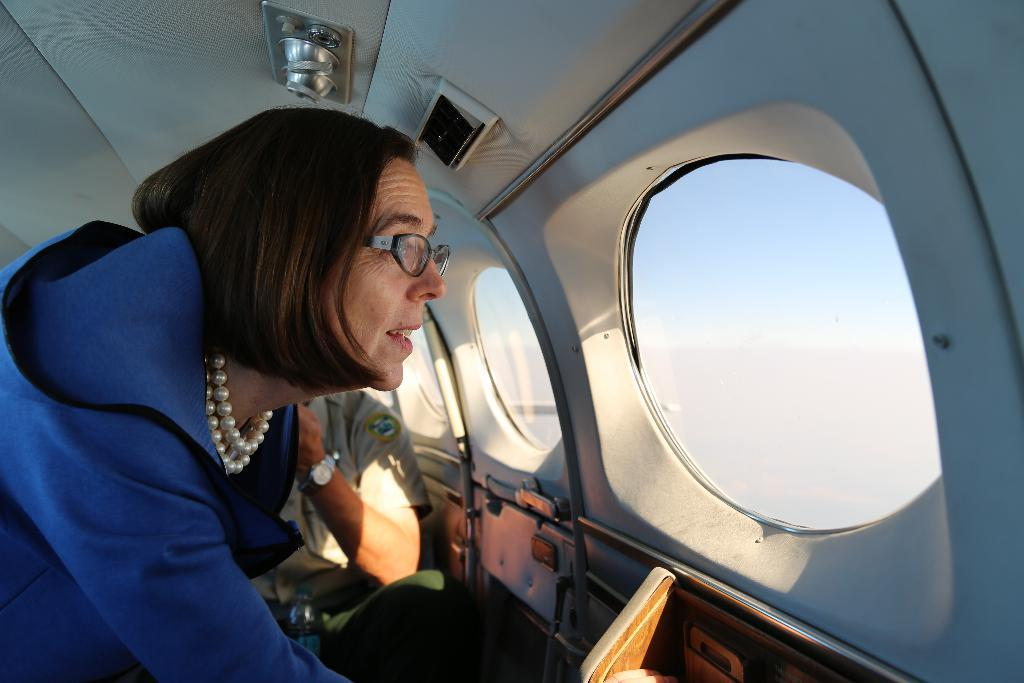What is the setting of the image? The image shows the inside of an aircraft. How many people are present in the image? There are two persons in the aircraft. What can be seen through the windows of the aircraft? The windows of the aircraft allow a view of the sky. What type of disease is affecting the passengers in the image? There is no indication of any disease affecting the passengers in the image. The image simply shows two people inside an aircraft with a view of the sky through the windows. 